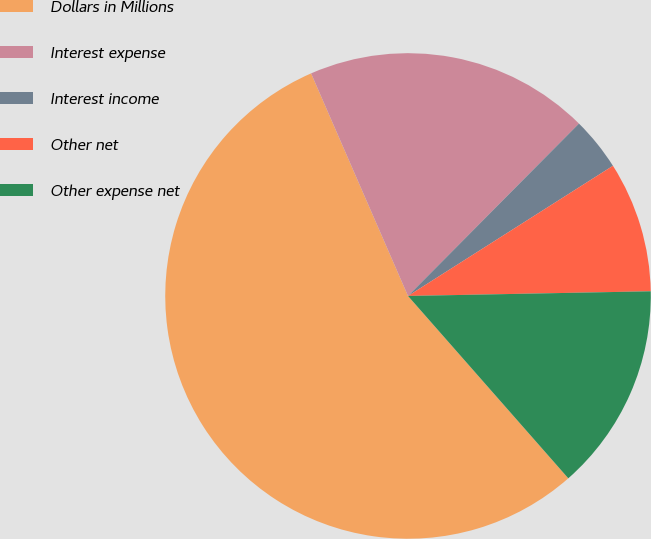Convert chart to OTSL. <chart><loc_0><loc_0><loc_500><loc_500><pie_chart><fcel>Dollars in Millions<fcel>Interest expense<fcel>Interest income<fcel>Other net<fcel>Other expense net<nl><fcel>54.94%<fcel>18.97%<fcel>3.56%<fcel>8.7%<fcel>13.83%<nl></chart> 